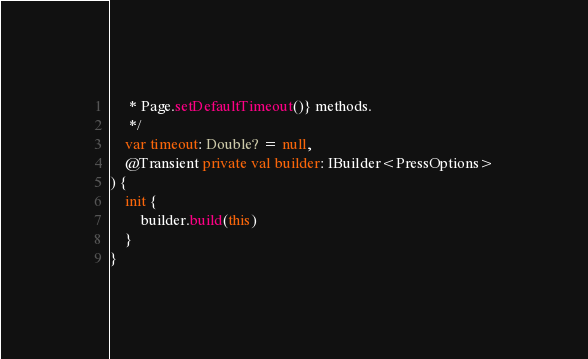Convert code to text. <code><loc_0><loc_0><loc_500><loc_500><_Kotlin_>     * Page.setDefaultTimeout()} methods.
     */
    var timeout: Double? = null,
    @Transient private val builder: IBuilder<PressOptions>
) {
    init {
        builder.build(this)
    }
}
</code> 